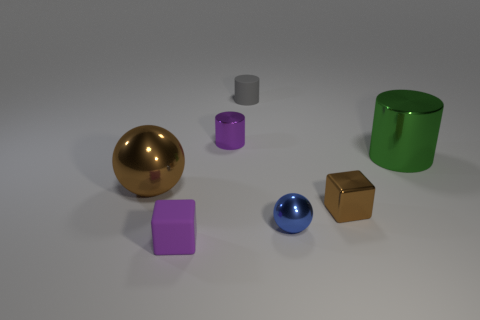Could this image be used to explain reflection and absorption of light? Definitely. This image is a great visual aid for explaining the concepts of light reflection and absorption. The metallic surfaces of the sphere and the cube reflect light, while the matte surfaces of the other objects absorb more light, resulting in less reflection and different visual textures. 